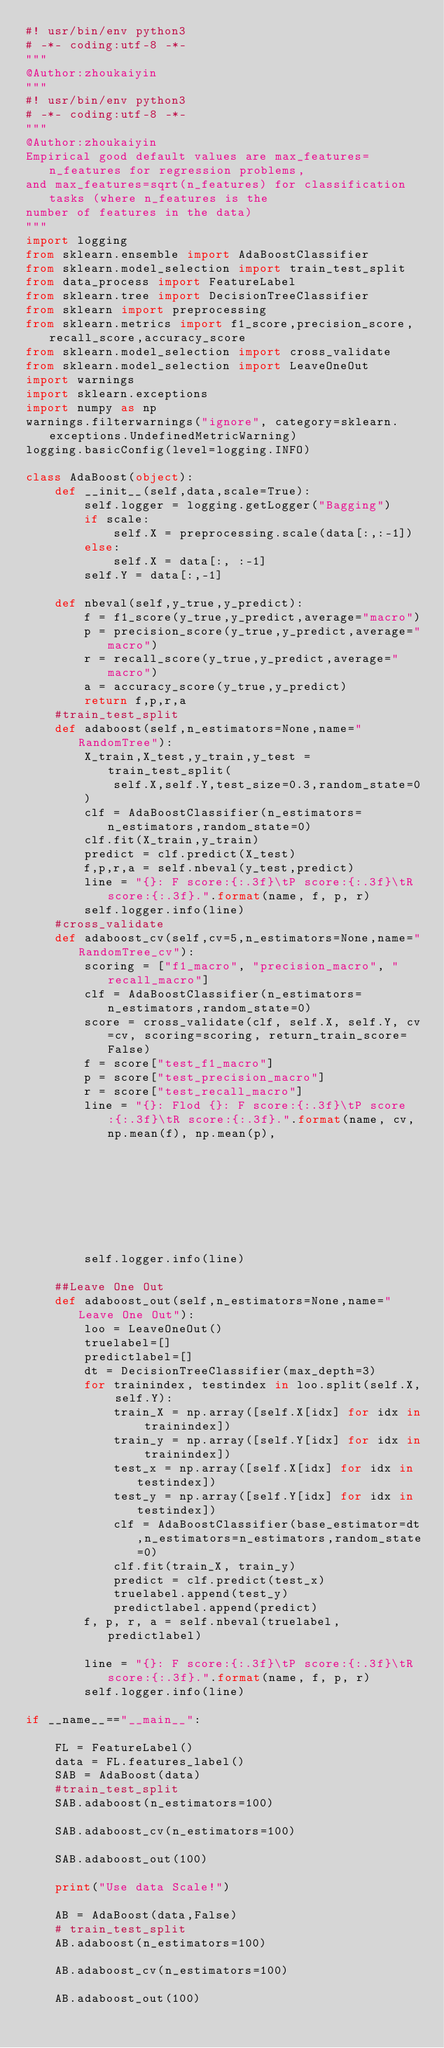Convert code to text. <code><loc_0><loc_0><loc_500><loc_500><_Python_>#! usr/bin/env python3
# -*- coding:utf-8 -*-
"""
@Author:zhoukaiyin
"""
#! usr/bin/env python3
# -*- coding:utf-8 -*-
"""
@Author:zhoukaiyin
Empirical good default values are max_features=n_features for regression problems, 
and max_features=sqrt(n_features) for classification tasks (where n_features is the
number of features in the data)
"""
import logging
from sklearn.ensemble import AdaBoostClassifier
from sklearn.model_selection import train_test_split
from data_process import FeatureLabel
from sklearn.tree import DecisionTreeClassifier
from sklearn import preprocessing
from sklearn.metrics import f1_score,precision_score,recall_score,accuracy_score
from sklearn.model_selection import cross_validate
from sklearn.model_selection import LeaveOneOut
import warnings
import sklearn.exceptions
import numpy as np
warnings.filterwarnings("ignore", category=sklearn.exceptions.UndefinedMetricWarning)
logging.basicConfig(level=logging.INFO)

class AdaBoost(object):
    def __init__(self,data,scale=True):
        self.logger = logging.getLogger("Bagging")
        if scale:
            self.X = preprocessing.scale(data[:,:-1])
        else:
            self.X = data[:, :-1]
        self.Y = data[:,-1]

    def nbeval(self,y_true,y_predict):
        f = f1_score(y_true,y_predict,average="macro")
        p = precision_score(y_true,y_predict,average="macro")
        r = recall_score(y_true,y_predict,average="macro")
        a = accuracy_score(y_true,y_predict)
        return f,p,r,a
    #train_test_split
    def adaboost(self,n_estimators=None,name="RandomTree"):
        X_train,X_test,y_train,y_test = train_test_split(
            self.X,self.Y,test_size=0.3,random_state=0
        )
        clf = AdaBoostClassifier(n_estimators=n_estimators,random_state=0)
        clf.fit(X_train,y_train)
        predict = clf.predict(X_test)
        f,p,r,a = self.nbeval(y_test,predict)
        line = "{}: F score:{:.3f}\tP score:{:.3f}\tR score:{:.3f}.".format(name, f, p, r)
        self.logger.info(line)
    #cross_validate
    def adaboost_cv(self,cv=5,n_estimators=None,name="RandomTree_cv"):
        scoring = ["f1_macro", "precision_macro", "recall_macro"]
        clf = AdaBoostClassifier(n_estimators=n_estimators,random_state=0)
        score = cross_validate(clf, self.X, self.Y, cv=cv, scoring=scoring, return_train_score=False)
        f = score["test_f1_macro"]
        p = score["test_precision_macro"]
        r = score["test_recall_macro"]
        line = "{}: Flod {}: F score:{:.3f}\tP score:{:.3f}\tR score:{:.3f}.".format(name, cv, np.mean(f), np.mean(p),
                                                                                     np.mean(r))
        self.logger.info(line)

    ##Leave One Out
    def adaboost_out(self,n_estimators=None,name="Leave One Out"):
        loo = LeaveOneOut()
        truelabel=[]
        predictlabel=[]
        dt = DecisionTreeClassifier(max_depth=3)
        for trainindex, testindex in loo.split(self.X, self.Y):
            train_X = np.array([self.X[idx] for idx in trainindex])
            train_y = np.array([self.Y[idx] for idx in trainindex])
            test_x = np.array([self.X[idx] for idx in testindex])
            test_y = np.array([self.Y[idx] for idx in testindex])
            clf = AdaBoostClassifier(base_estimator=dt,n_estimators=n_estimators,random_state=0)
            clf.fit(train_X, train_y)
            predict = clf.predict(test_x)
            truelabel.append(test_y)
            predictlabel.append(predict)
        f, p, r, a = self.nbeval(truelabel, predictlabel)

        line = "{}: F score:{:.3f}\tP score:{:.3f}\tR score:{:.3f}.".format(name, f, p, r)
        self.logger.info(line)

if __name__=="__main__":

    FL = FeatureLabel()
    data = FL.features_label()
    SAB = AdaBoost(data)
    #train_test_split
    SAB.adaboost(n_estimators=100)

    SAB.adaboost_cv(n_estimators=100)

    SAB.adaboost_out(100)

    print("Use data Scale!")

    AB = AdaBoost(data,False)
    # train_test_split
    AB.adaboost(n_estimators=100)

    AB.adaboost_cv(n_estimators=100)

    AB.adaboost_out(100)


</code> 